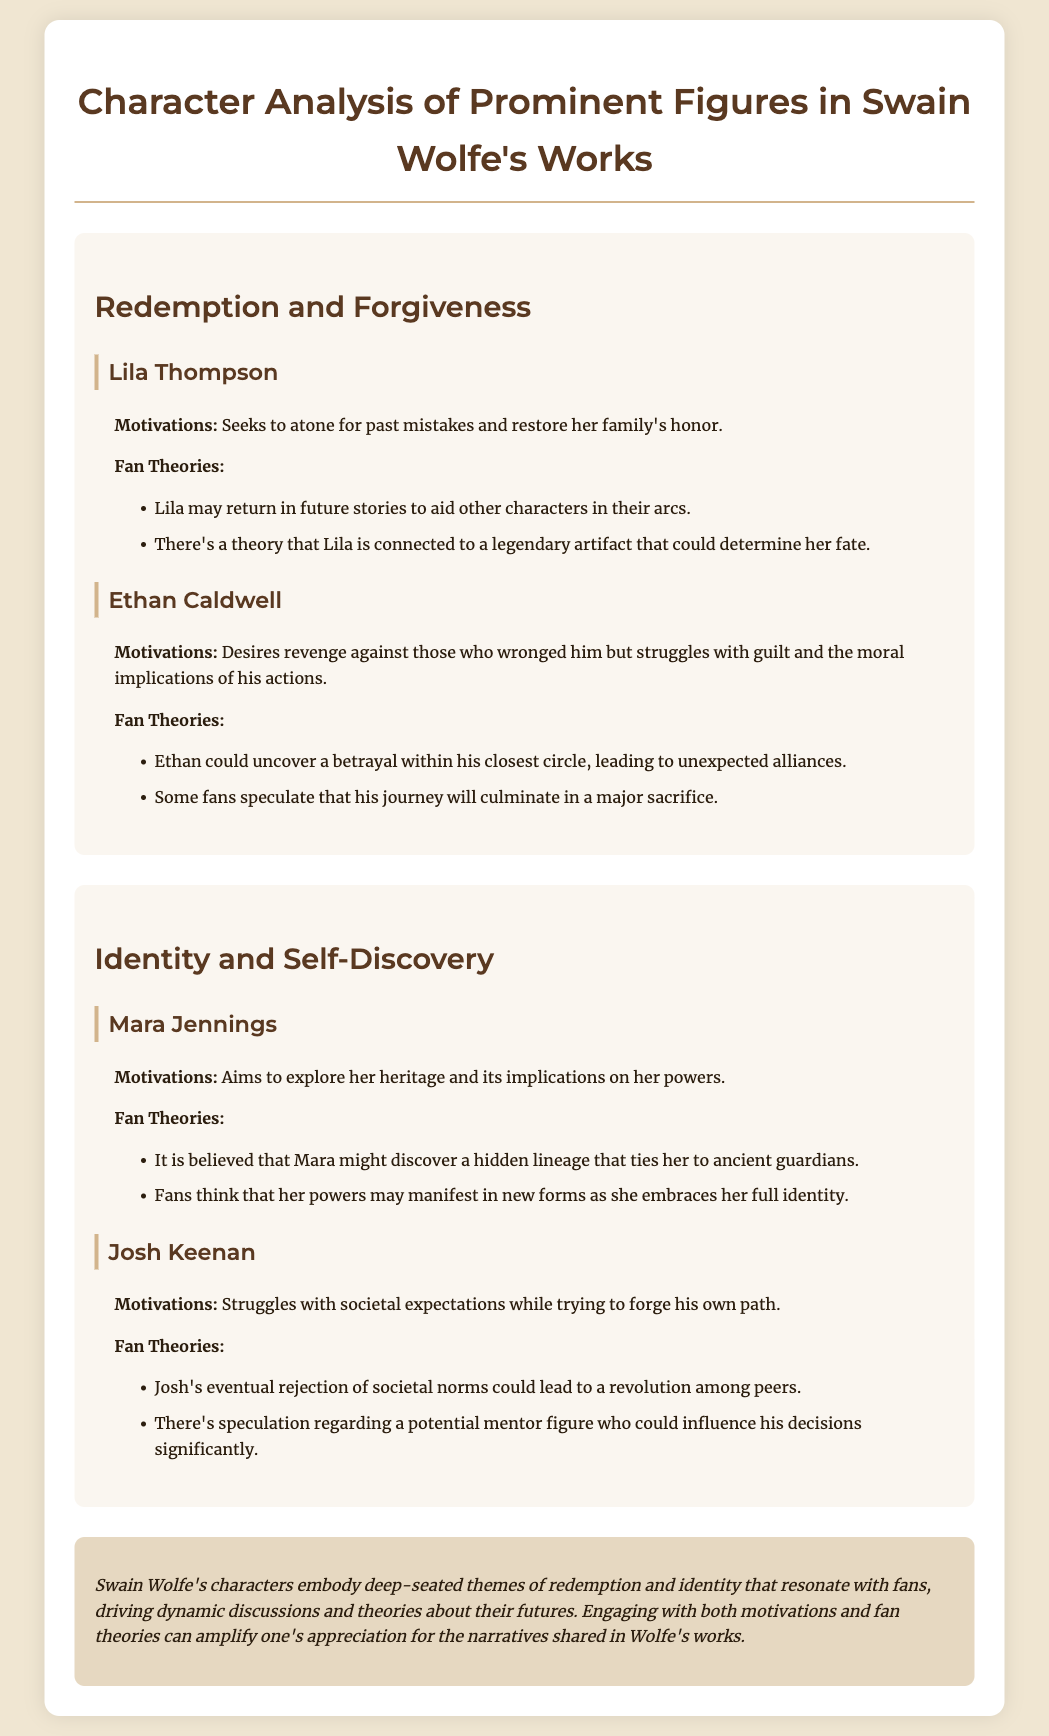What is the main theme discussed in the document? The document highlights themes of redemption, forgiveness, identity, and self-discovery throughout Swain Wolfe's works.
Answer: Redemption and Forgiveness Who is a character seeking to restore her family's honor? Lila Thompson is mentioned as seeking to atone for past mistakes and restore her family's honor.
Answer: Lila Thompson What motivates Ethan Caldwell's actions? Ethan Caldwell is motivated by a desire for revenge against those who wronged him.
Answer: Revenge Which character aims to explore her heritage? Mara Jennings aims to explore her heritage and its implications on her powers.
Answer: Mara Jennings What is a fan theory about Josh Keenan? One fan theory suggests that Josh's rejection of societal norms could lead to a revolution among peers.
Answer: Revolution among peers Which character has a connection to a legendary artifact? The document theorizes that Lila may be connected to a legendary artifact that could determine her fate.
Answer: Lila How many characters are analyzed under the theme of "Identity and Self-Discovery"? Two characters are analyzed under this theme: Mara Jennings and Josh Keenan.
Answer: Two What speculation exists regarding Ethan Caldwell's journey? Some fans speculate that Ethan's journey will culminate in a major sacrifice.
Answer: Major sacrifice What is the character analysis document primarily focused on? The document focuses on character analysis, motivations, themes, and fan theories related to Swain Wolfe's works.
Answer: Character analysis 